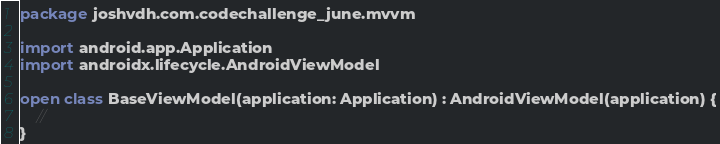Convert code to text. <code><loc_0><loc_0><loc_500><loc_500><_Kotlin_>package joshvdh.com.codechallenge_june.mvvm

import android.app.Application
import androidx.lifecycle.AndroidViewModel

open class BaseViewModel(application: Application) : AndroidViewModel(application) {
    //
}</code> 